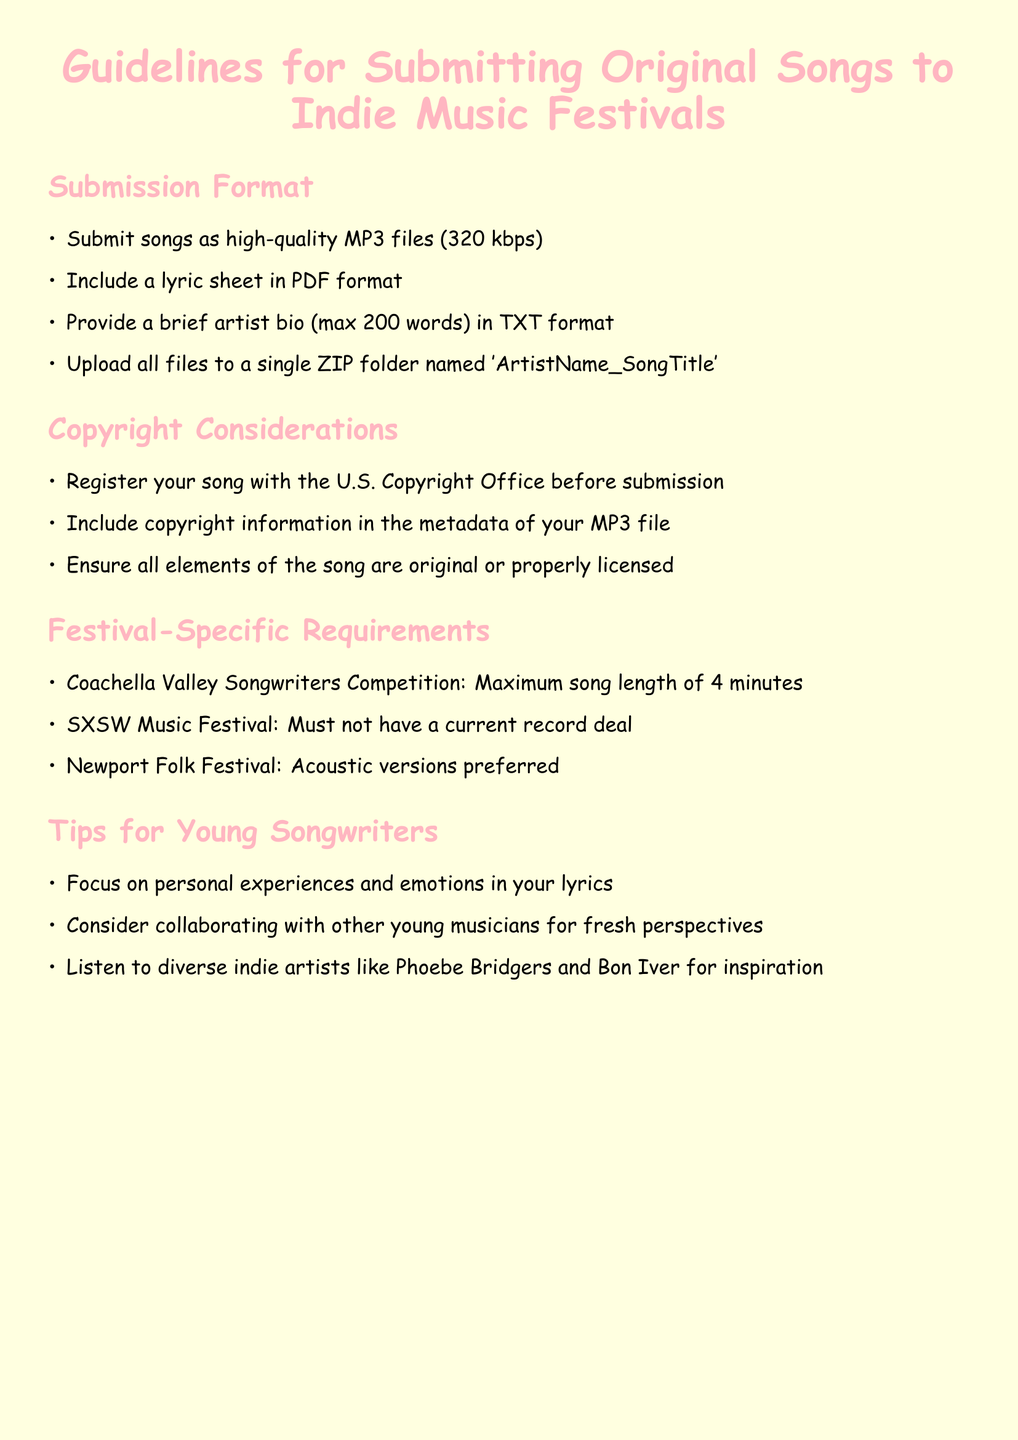what file format should the songs be submitted in? The document states that songs should be submitted as high-quality MP3 files.
Answer: MP3 what is the maximum length for songs submitted to the Coachella Valley Songwriters Competition? The document specifies a maximum song length of 4 minutes for this competition.
Answer: 4 minutes what should be included with the MP3 file submission? The document indicates that a lyric sheet and a brief artist bio should be included with the MP3 file.
Answer: lyric sheet and artist bio who should be registered with the U.S. Copyright Office before submission? The guidelines suggest that songwriters must register their songs before submission.
Answer: songwriters what type of versions does the Newport Folk Festival prefer? The guidelines state that acoustic versions are preferred for this festival.
Answer: Acoustic what is the maximum word count for the artist bio? The document specifies a maximum word count of 200 words for the artist bio.
Answer: 200 words what does the document recommend as a source of inspiration for young songwriters? The document advises listening to diverse indie artists for inspiration.
Answer: diverse indie artists what should be included in the metadata of the MP3 file? According to the document, copyright information should be included in the metadata of the MP3 file.
Answer: copyright information 